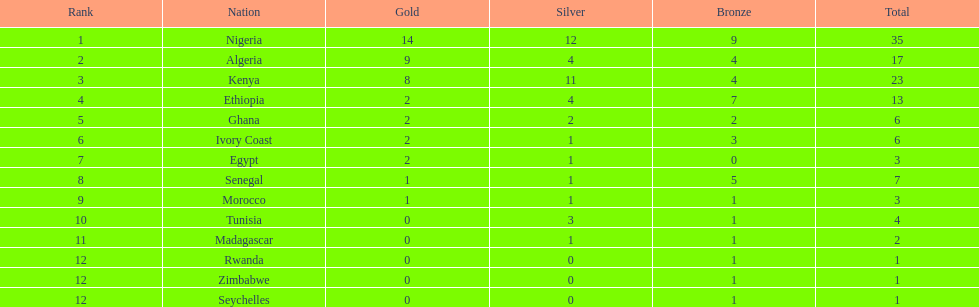Give me the full table as a dictionary. {'header': ['Rank', 'Nation', 'Gold', 'Silver', 'Bronze', 'Total'], 'rows': [['1', 'Nigeria', '14', '12', '9', '35'], ['2', 'Algeria', '9', '4', '4', '17'], ['3', 'Kenya', '8', '11', '4', '23'], ['4', 'Ethiopia', '2', '4', '7', '13'], ['5', 'Ghana', '2', '2', '2', '6'], ['6', 'Ivory Coast', '2', '1', '3', '6'], ['7', 'Egypt', '2', '1', '0', '3'], ['8', 'Senegal', '1', '1', '5', '7'], ['9', 'Morocco', '1', '1', '1', '3'], ['10', 'Tunisia', '0', '3', '1', '4'], ['11', 'Madagascar', '0', '1', '1', '2'], ['12', 'Rwanda', '0', '0', '1', '1'], ['12', 'Zimbabwe', '0', '0', '1', '1'], ['12', 'Seychelles', '0', '0', '1', '1']]} Which country had the least bronze medals? Egypt. 